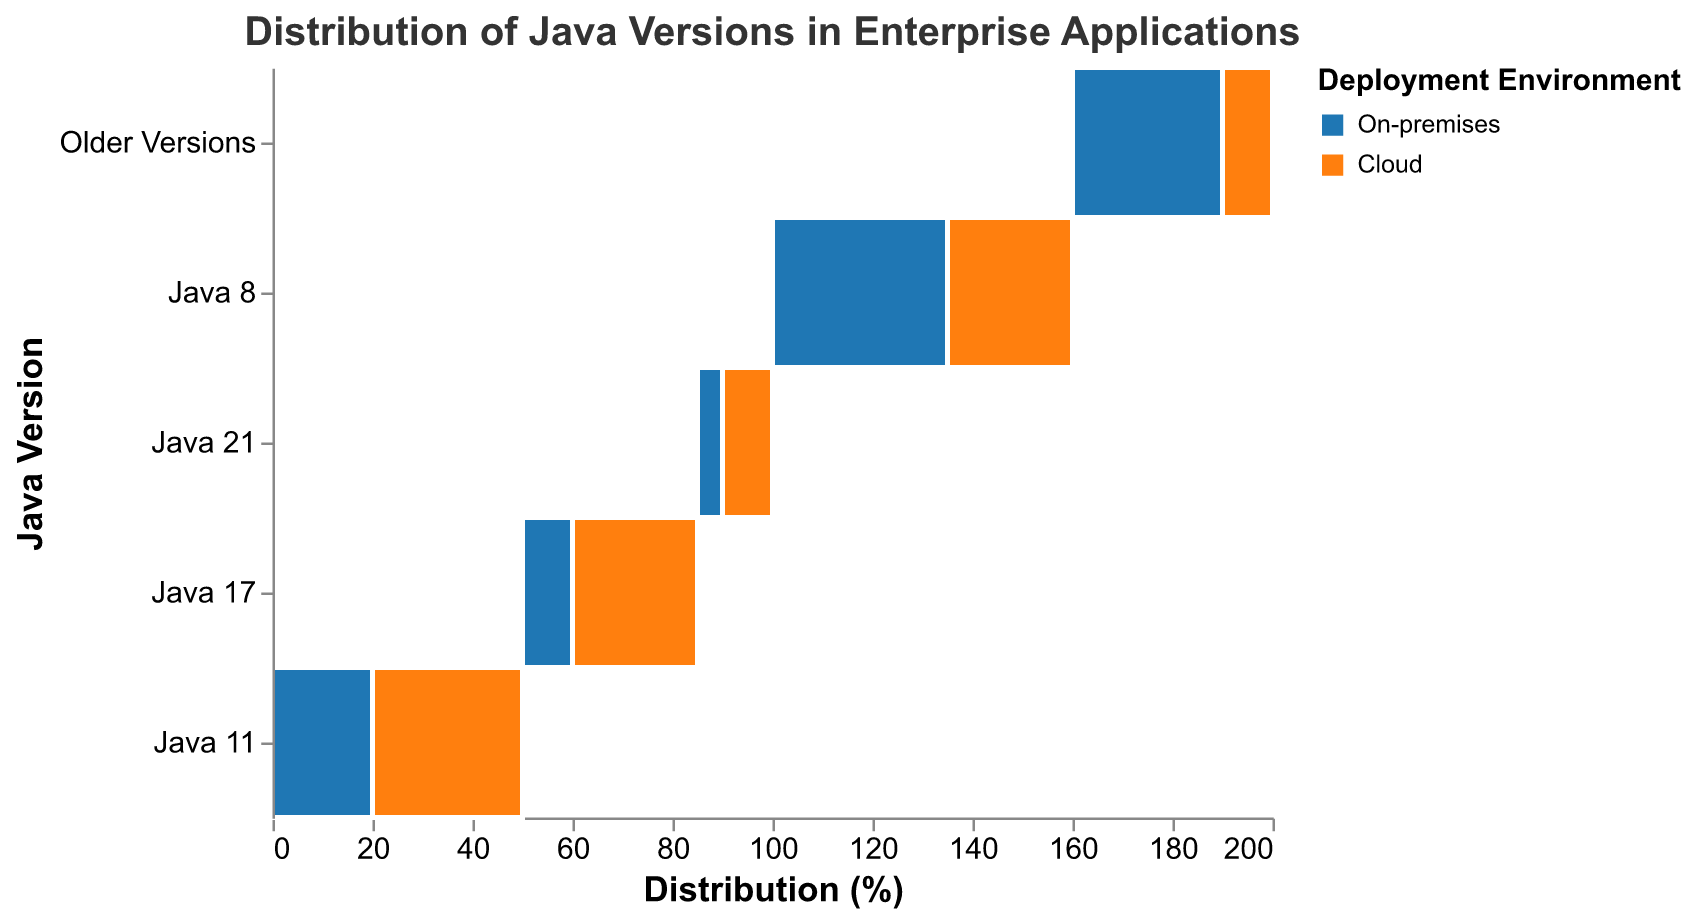What is the title of the figure? The title of the figure is usually displayed at the top. In this case, it reads "Distribution of Java Versions in Enterprise Applications".
Answer: Distribution of Java Versions in Enterprise Applications How many deployment environments are shown in the plot? The colors of the bars represent different deployment environments. There are two distinct colors, which represent the two deployment environments indicated in the legend: On-premises and Cloud.
Answer: 2 Which Java version has the highest percentage in the On-premises environment? By looking at the segments in the plot on the Y axis labeled 'On-premises' and comparing their sizes, Java 8 stands out as having the largest segment for the On-premises environment.
Answer: Java 8 What is the total distribution percentage of Java 11 across all deployment environments? First, identify each segment representing Java 11 in both On-premises (20%) and Cloud (30%) from the plot, then sum these percentages: 20% + 30% = 50%.
Answer: 50% In which deployment environment is Java 17 more widely used? Compare the sizes of the segments for Java 17 in On-premises and Cloud. The Cloud segment is larger.
Answer: Cloud What is the difference in percentage between Java 8 in On-premises and Cloud environments? Identify the percentage of Java 8 in On-premises (35%) and Cloud (25%), then subtract the smaller from the larger: 35% - 25% = 10%.
Answer: 10% Which has a higher percentage of usage in the Cloud environment, Java 11 or Java 17? Compare the segments for Java 11 (30%) and Java 17 (25%) in the Cloud environment; Java 11 has a higher percentage than Java 17.
Answer: Java 11 Calculate the combined percentage for 'Older Versions' in all deployment environments. Sum the percentages for Older Versions in On-premises (30%) and Cloud (10%): 30% + 10% = 40%.
Answer: 40% Which deployment environment has a higher percentage of usage of Java 21? Compare the segments for Java 21 in On-premises (5%) and Cloud (10%), Cloud has a higher percentage.
Answer: Cloud 